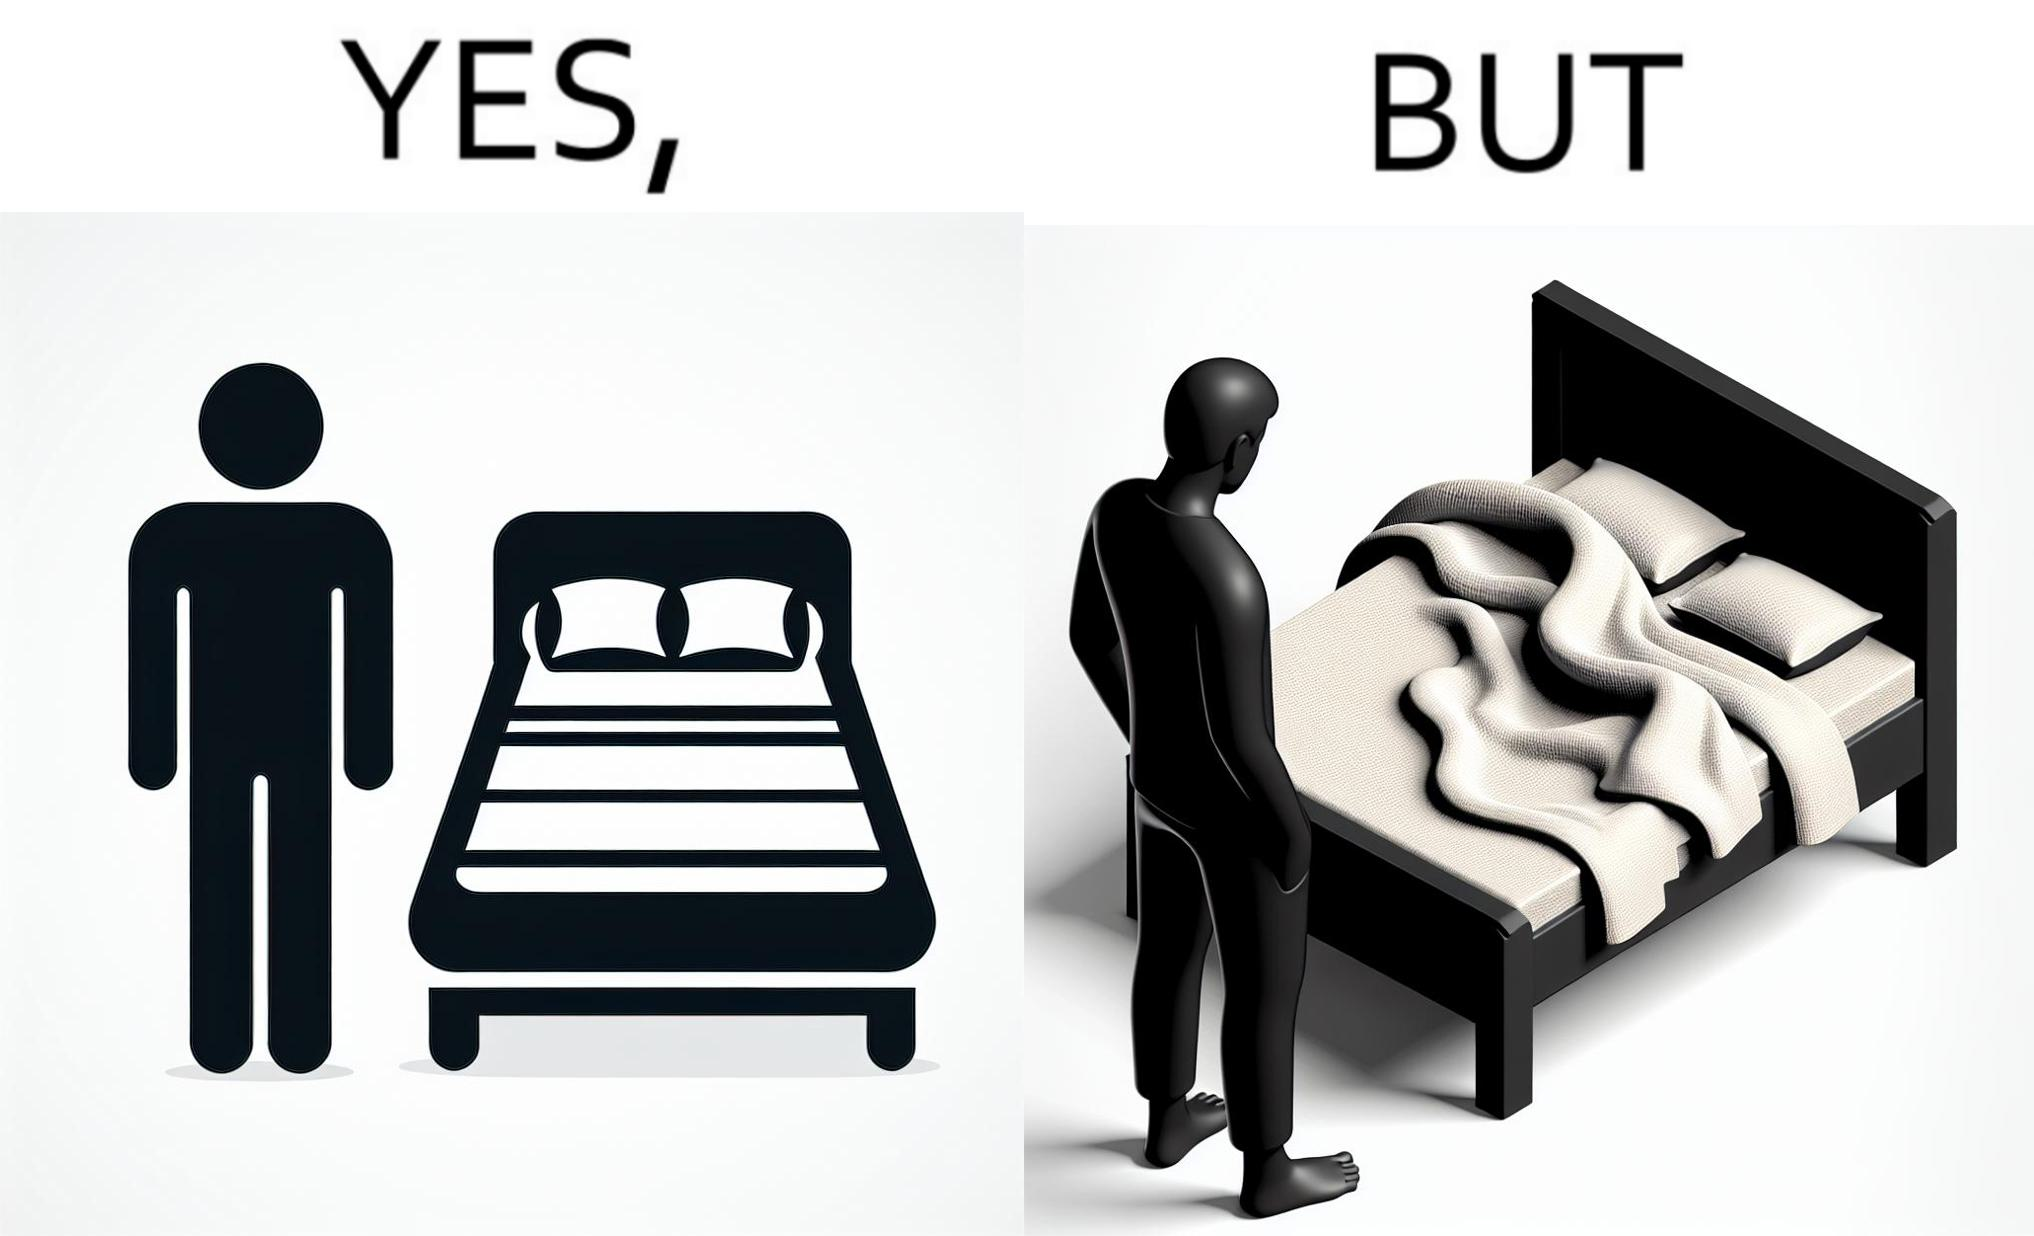Why is this image considered satirical? The image is funny because while the bed seems to be well made with the blanket on top, the actual blanket inside the blanket cover is twisted and not properly set. 